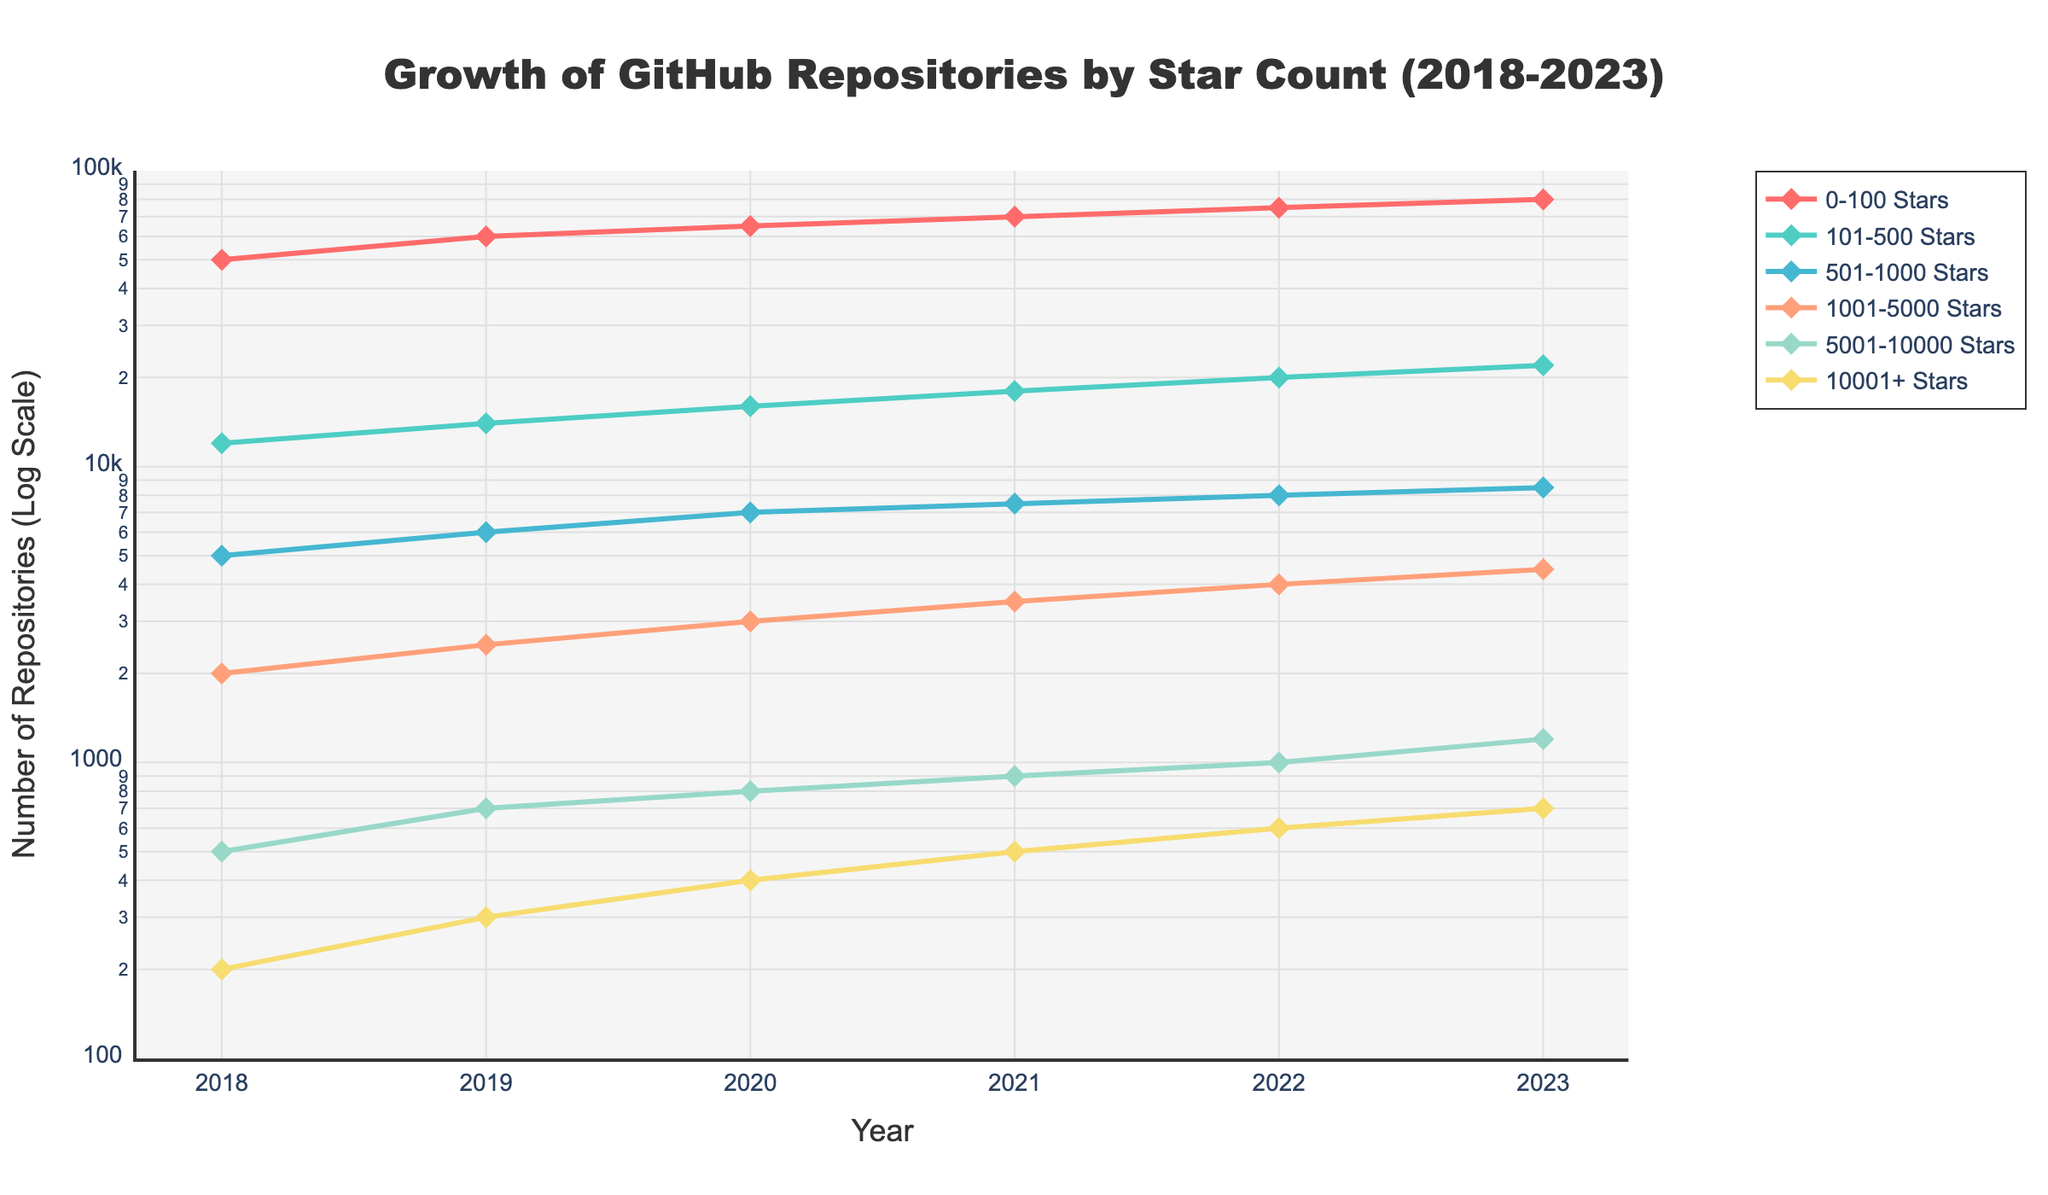what is the title of the plot? The title of the plot is usually located at the top of the figure, written in larger and bold text. Observing the top part of the figure, the title reads "Growth of GitHub Repositories by Star Count (2018-2023)."
Answer: "Growth of GitHub Repositories by Star Count (2018-2023)" what is the y-axis title? The y-axis title is commonly positioned next to the y-axis on the left side of the plot. In this figure, it reads "Number of Repositories (Log Scale)."
Answer: "Number of Repositories (Log Scale)" what are the colors representing different star count categories? The colors can be identified by observing the lines and markers in the plots and the legend. The categories are represented by the following colors: 0-100 Stars is red, 101-500 Stars is green, 501-1000 Stars is light blue, 1001-5000 Stars is orange, 5001-10000 Stars is light green, and 10001+ Stars is yellow.
Answer: Red, green, light blue, orange, light green, yellow which star count category showed the highest growth in repositories from 2018 to 2023? To determine the highest growth, we look at the starting and ending values of each category. The 0-100 Stars category grew from 50000 to 80000, which is the largest increase compared to other categories.
Answer: 0-100 Stars Which year had the biggest increase in repositories for the 101-500 Stars category? By looking at the differences between subsequent years for the 101-500 Stars category: 2018-2019 saw an increase from 12000 to 14000 (2000), 2019-2020 (2000), 2020-2021 (2000), 2021-2022 (2000), 2022-2023 (2000). All these increments are equal, so there is no single biggest increase.
Answer: All increases are equal In which year do repositories with 10001+ stars surpass 500? To find this, we look at the relevant data points. In 2021, repositories with 10001+ stars are 500, and in 2022, they are 600, surpassing 500 for the first time.
Answer: 2022 Are there any years where the number of repositories with 0-100 Stars decreased? By examining the line plot for the 0-100 Stars category, we observe a consistent upward trend each year from 2018 to 2023 with no decreases.
Answer: No What is the cumulative total of repositories with 5001-10000 Stars in 2020 and 2021? Summing the number of repositories with 5001-10000 Stars in 2020 (800) and 2021 (900), we get a total of 800 + 900 = 1700.
Answer: 1700 How does the growth trend of repositories with 1001-5000 Stars compare to those with 501-1000 Stars? By comparing the slopes of the respective lines, both show steady increases over the years but the 1001-5000 Stars category starts lower and ends higher than the 501-1000 Stars category, indicating a slightly faster growth trend.
Answer: Slightly faster growth trend in 1001-5000 Stars 